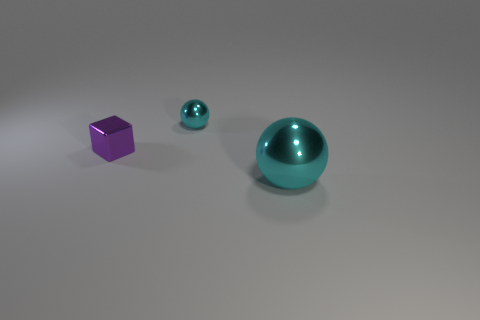Add 1 big metallic spheres. How many objects exist? 4 Subtract all blocks. How many objects are left? 2 Add 3 big metal things. How many big metal things exist? 4 Subtract 0 cyan blocks. How many objects are left? 3 Subtract all purple objects. Subtract all large cyan metallic things. How many objects are left? 1 Add 2 big shiny spheres. How many big shiny spheres are left? 3 